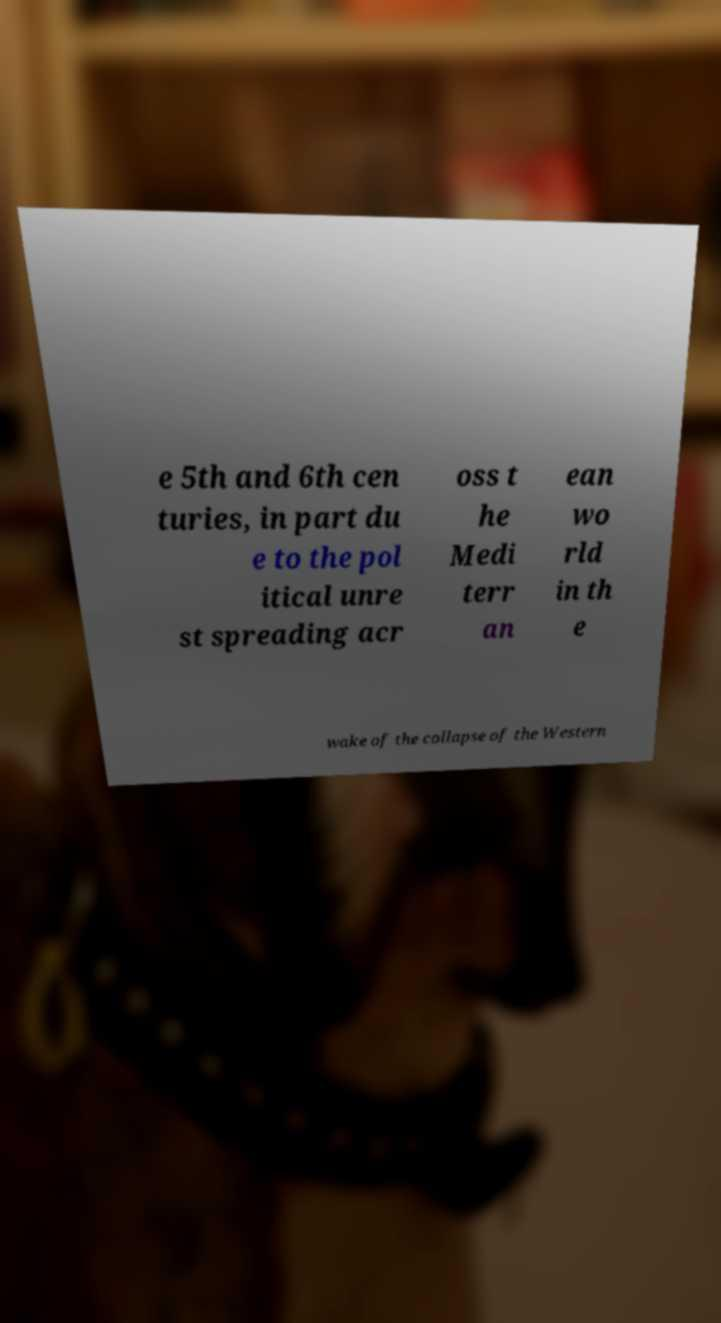What messages or text are displayed in this image? I need them in a readable, typed format. e 5th and 6th cen turies, in part du e to the pol itical unre st spreading acr oss t he Medi terr an ean wo rld in th e wake of the collapse of the Western 